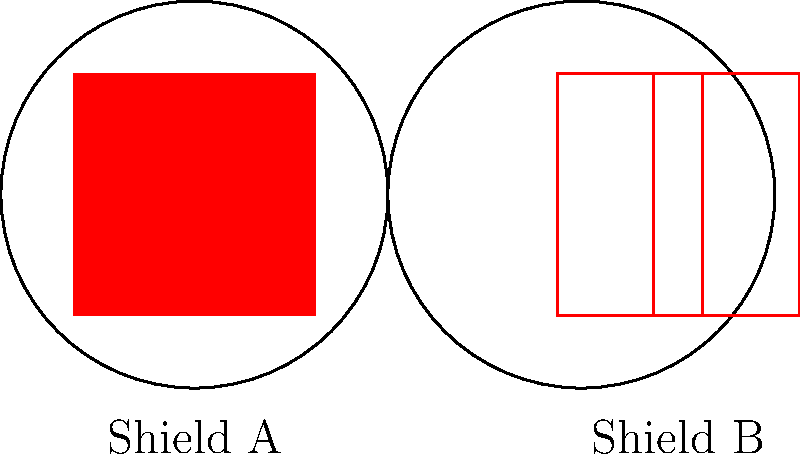Analyze the congruence of religious iconography on the two Crusader shields depicted above. Which geometric transformation would be necessary to make the cross on Shield A congruent to the cross on Shield B? To determine the geometric transformation needed to make the cross on Shield A congruent to the cross on Shield B, we need to follow these steps:

1. Observe the characteristics of both crosses:
   - Shield A: The cross is wider and occupies more space on the shield.
   - Shield B: The cross is narrower and occupies less space on the shield.

2. Compare the dimensions:
   - The vertical length of both crosses appears to be the same, extending from the top to the bottom of the shield.
   - The horizontal width of the cross on Shield B is noticeably smaller than the one on Shield A.

3. Identify the transformation:
   - Since the vertical length remains the same, we don't need to scale the entire cross.
   - The horizontal width needs to be reduced to match Shield B.
   - This transformation is known as a horizontal compression or scaling.

4. Determine the scale factor:
   - The exact scale factor would depend on the precise measurements, but visually it appears that the horizontal width of the cross on Shield B is about 1/5 of the width of the cross on Shield A.

5. Express the transformation mathematically:
   - If we consider the horizontal scaling factor as $k$ (where $0 < k < 1$), the transformation can be expressed as $f(x,y) = (kx, y)$.

Therefore, the geometric transformation necessary to make the cross on Shield A congruent to the cross on Shield B is a horizontal compression (or scaling) with a factor less than 1, applied only to the x-coordinates while leaving the y-coordinates unchanged.
Answer: Horizontal compression 